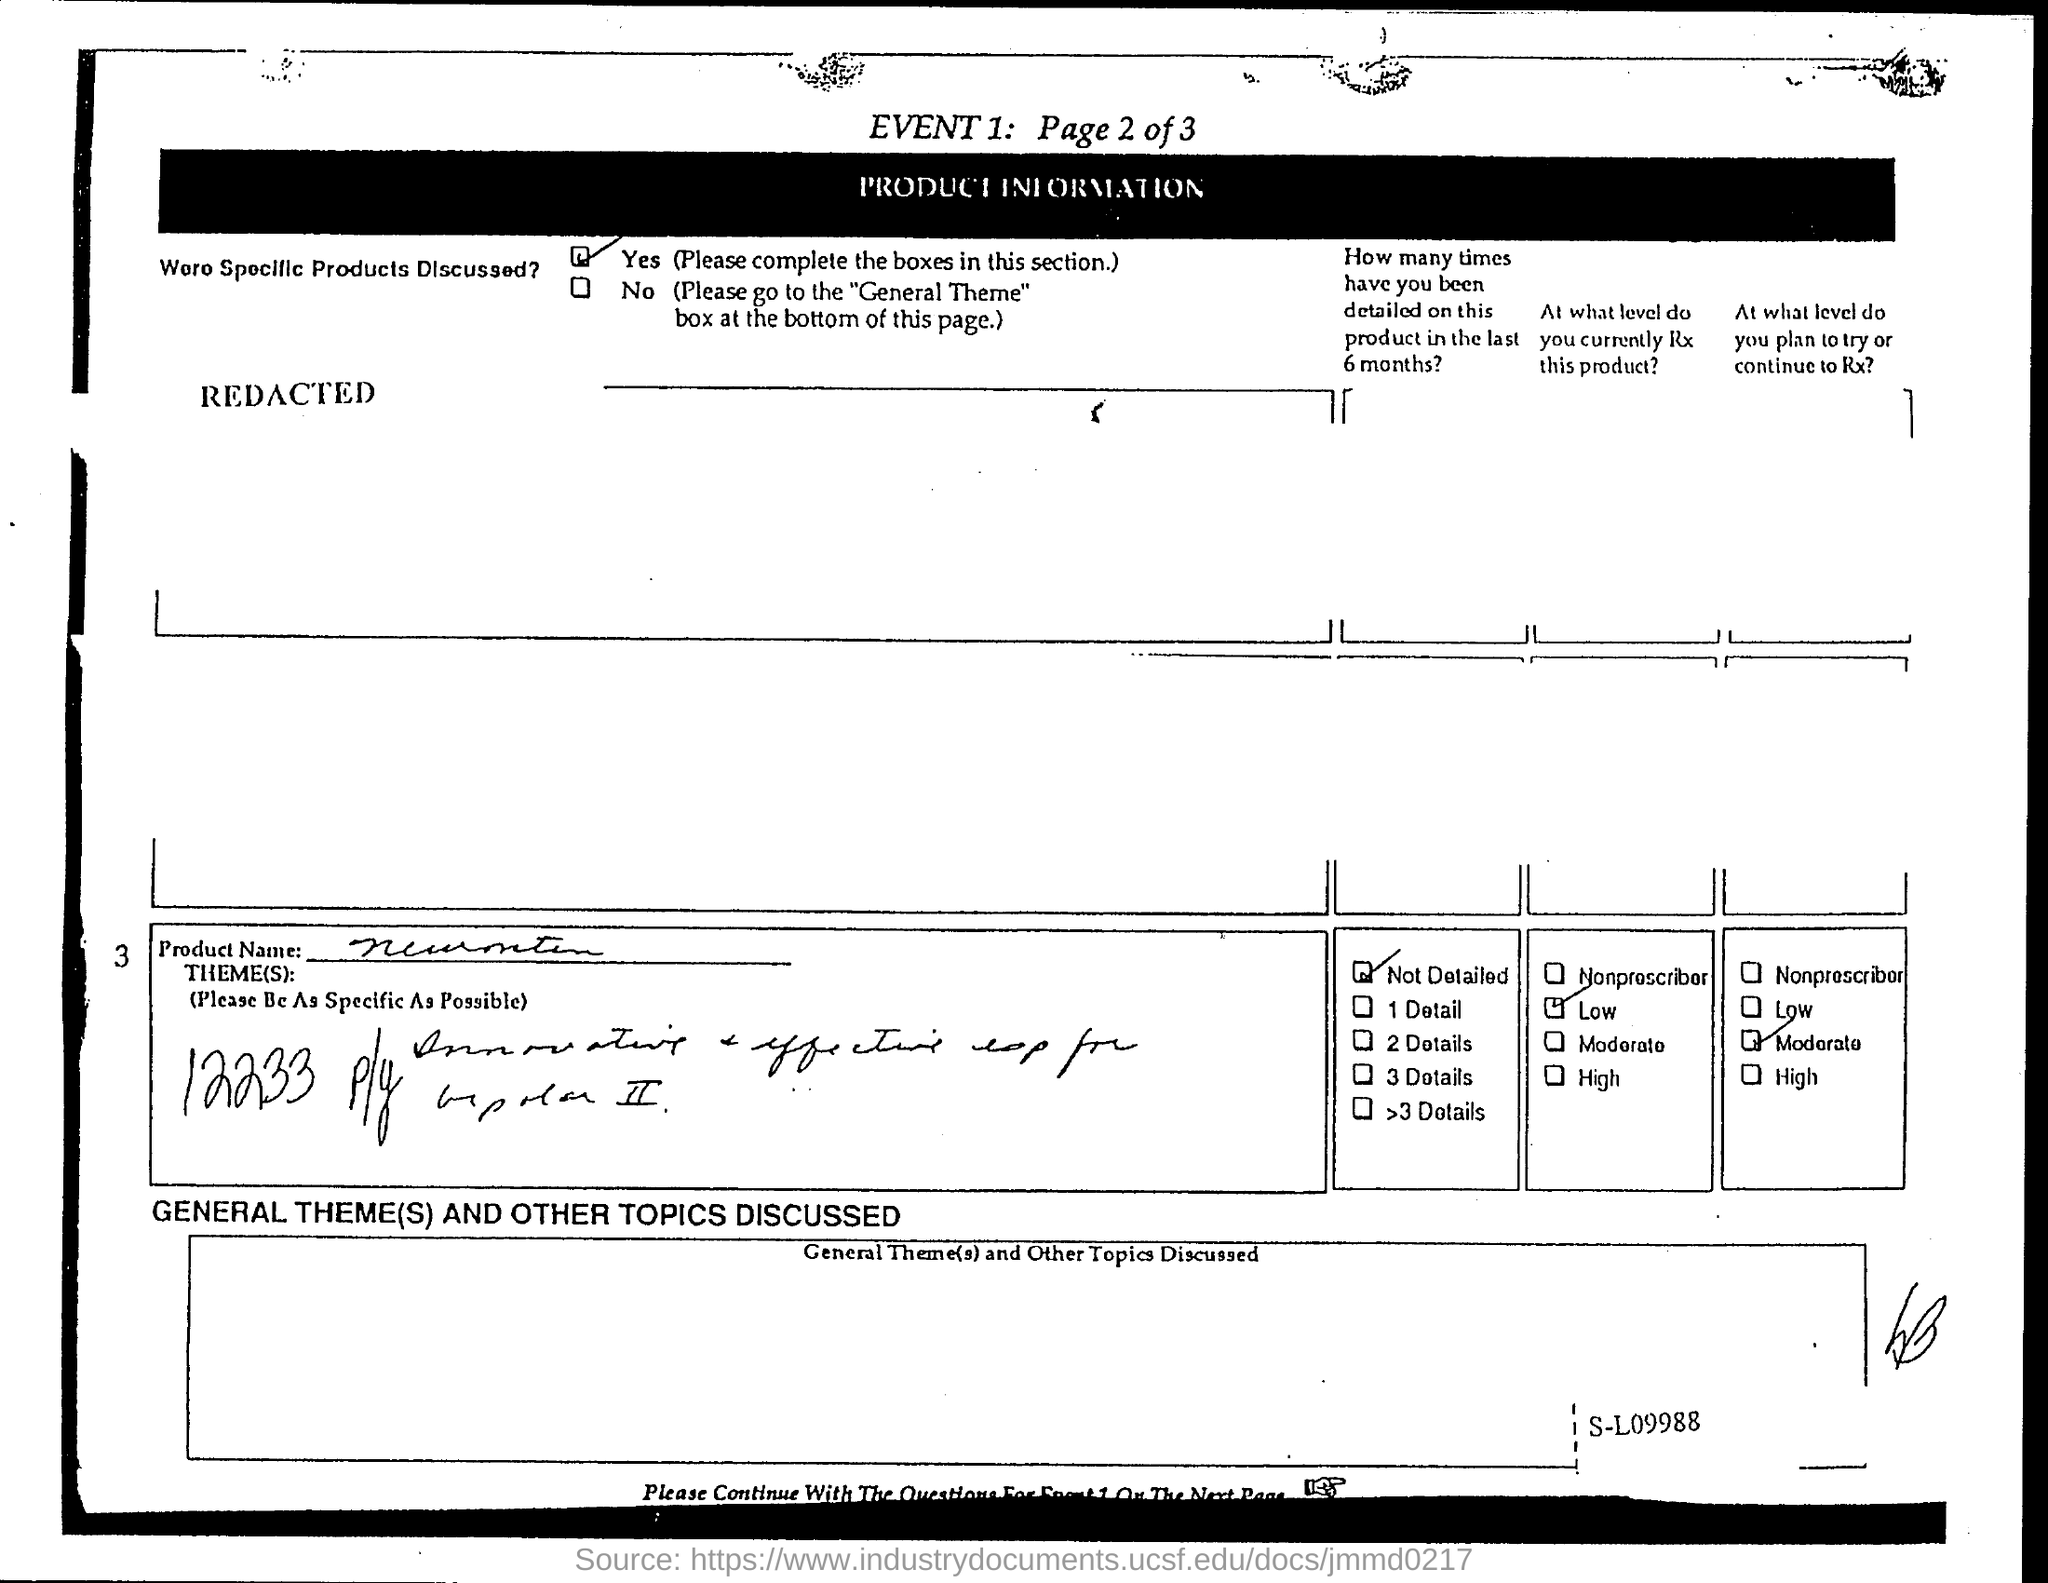Were specific products discussed?
Provide a short and direct response. Yes. 